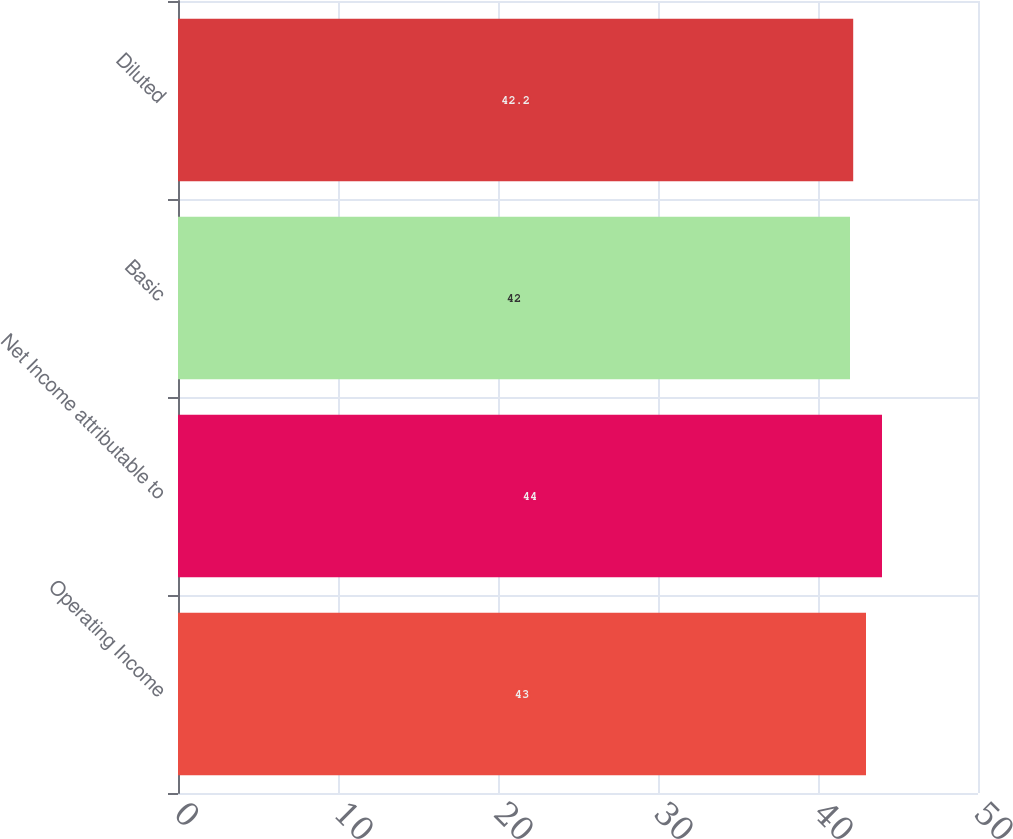<chart> <loc_0><loc_0><loc_500><loc_500><bar_chart><fcel>Operating Income<fcel>Net Income attributable to<fcel>Basic<fcel>Diluted<nl><fcel>43<fcel>44<fcel>42<fcel>42.2<nl></chart> 